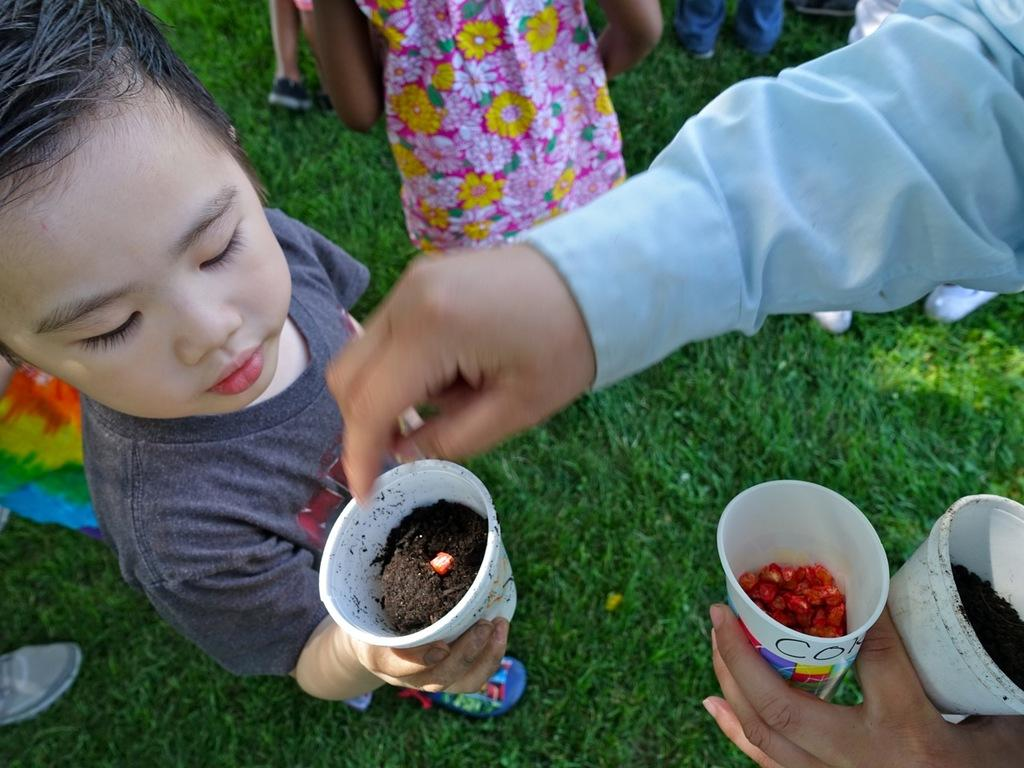What is the main subject of the image? There is a child in the image. What is the child wearing? The child is wearing clothes and shoes. What is the child holding in their hand? The child is holding a glass in their hand. Are there other people around the child in the image? Yes, there are other people around the child in the image. What are the other people wearing? The other people are wearing clothes. What type of environment is visible in the image? There is grass visible in the image. Can you tell me how many rabbits are playing in the yard in the image? There are no rabbits or yards present in the image; it features a child and other people in a grassy environment. 